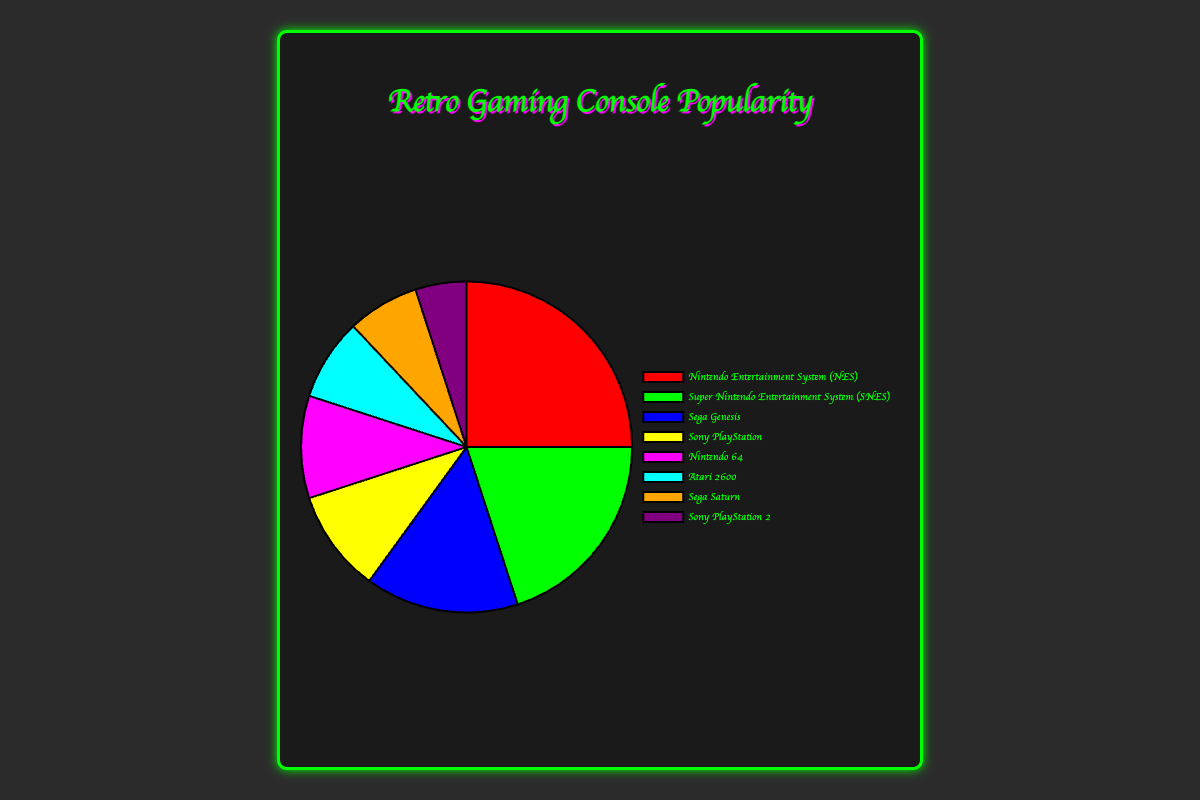What percentage of the pie chart does Nintendo Entertainment System (NES) occupy? The NES occupies 25% of the pie chart, which can be directly observed from the figure showing its proportion.
Answer: 25% Which console is more popular, Sega Genesis or Sony PlayStation? The Sega Genesis has a popularity percentage of 15%, while the Sony PlayStation has 10%, making the Sega Genesis more popular.
Answer: Sega Genesis What is the combined popularity percentage of the Sony PlayStation and Nintendo 64? The Sony PlayStation has a 10% popularity, and the Nintendo 64 also has 10%. Combined, their popularity is 10% + 10% = 20%.
Answer: 20% Which console has the smallest popularity percentage, and what is it? The Sony PlayStation 2 has the smallest popularity percentage at 5%, which can be observed as the smallest slice in the pie chart.
Answer: Sony PlayStation 2, 5% Compare the combined popularity of Atari 2600 and Sega Saturn to the popularity of the NES. Which is greater? The Atari 2600 has 8% and the Sega Saturn has 7%, totaling 15%. The NES has a popularity of 25%. Therefore, the NES is more popular than the combined total of Atari 2600 and Sega Saturn.
Answer: NES If you sum the popularity of all the consoles except NES and SNES, what is the total percentage? The total percentage of all consoles is 100%. Subtracting the NES (25%) and SNES (20%), the remaining percentage is 55%.
Answer: 55% What is the average popularity percentage of Sega Genesis, Atari 2600, and Sega Saturn? Sum of their popularity percentages is 15% (Sega Genesis) + 8% (Atari 2600) + 7% (Sega Saturn) = 30%. The average is 30% / 3 = 10%.
Answer: 10% Which consoles have a popularity percentage of at least 10%? The consoles with a popularity of at least 10% are NES (25%), SNES (20%), Sega Genesis (15%), Sony PlayStation (10%), and Nintendo 64 (10%).
Answer: NES, SNES, Sega Genesis, Sony PlayStation, Nintendo 64 